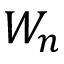<formula> <loc_0><loc_0><loc_500><loc_500>W _ { n }</formula> 